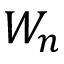<formula> <loc_0><loc_0><loc_500><loc_500>W _ { n }</formula> 